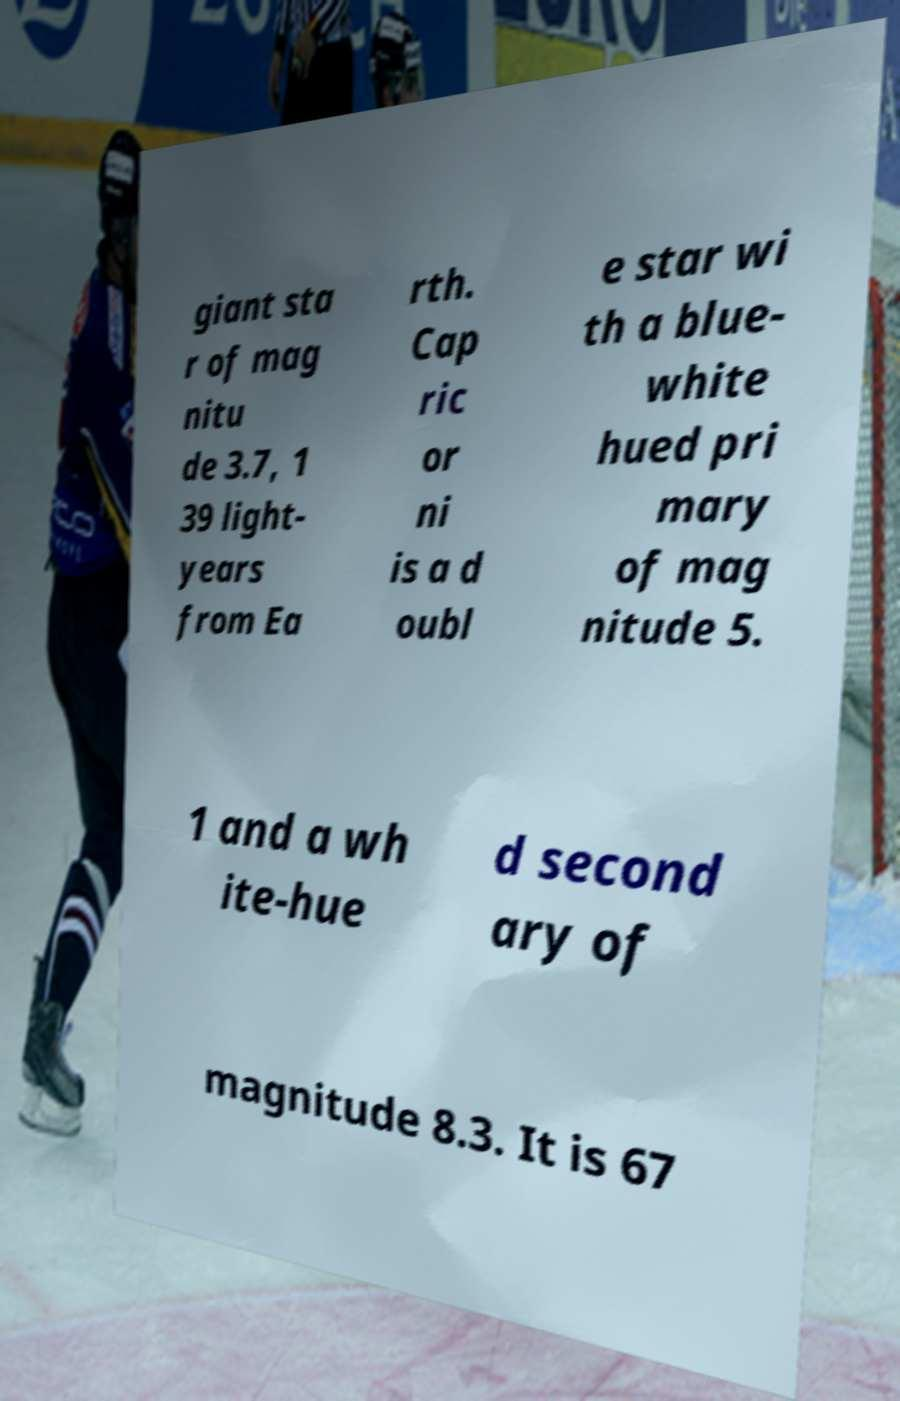Could you assist in decoding the text presented in this image and type it out clearly? giant sta r of mag nitu de 3.7, 1 39 light- years from Ea rth. Cap ric or ni is a d oubl e star wi th a blue- white hued pri mary of mag nitude 5. 1 and a wh ite-hue d second ary of magnitude 8.3. It is 67 